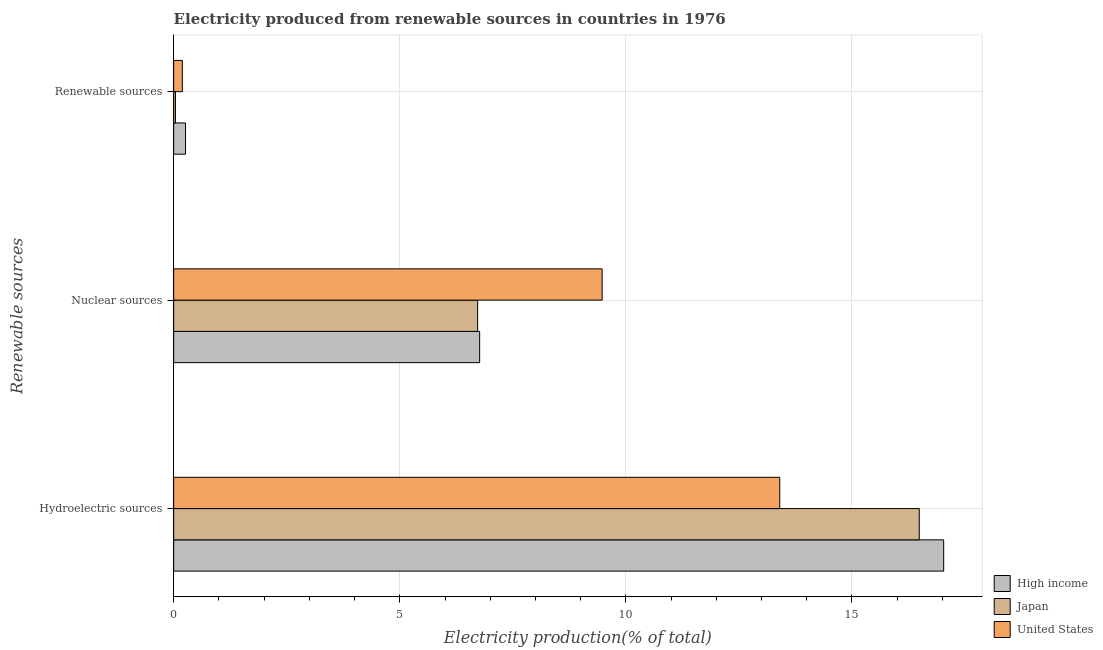Are the number of bars on each tick of the Y-axis equal?
Your answer should be compact. Yes. How many bars are there on the 2nd tick from the top?
Provide a succinct answer. 3. What is the label of the 2nd group of bars from the top?
Your answer should be compact. Nuclear sources. What is the percentage of electricity produced by nuclear sources in United States?
Provide a short and direct response. 9.47. Across all countries, what is the maximum percentage of electricity produced by nuclear sources?
Offer a terse response. 9.47. Across all countries, what is the minimum percentage of electricity produced by renewable sources?
Your answer should be very brief. 0.04. In which country was the percentage of electricity produced by renewable sources maximum?
Keep it short and to the point. High income. What is the total percentage of electricity produced by renewable sources in the graph?
Your response must be concise. 0.49. What is the difference between the percentage of electricity produced by renewable sources in Japan and that in High income?
Offer a very short reply. -0.22. What is the difference between the percentage of electricity produced by renewable sources in High income and the percentage of electricity produced by hydroelectric sources in United States?
Make the answer very short. -13.14. What is the average percentage of electricity produced by renewable sources per country?
Provide a succinct answer. 0.16. What is the difference between the percentage of electricity produced by nuclear sources and percentage of electricity produced by hydroelectric sources in High income?
Your response must be concise. -10.26. In how many countries, is the percentage of electricity produced by renewable sources greater than 8 %?
Your answer should be very brief. 0. What is the ratio of the percentage of electricity produced by hydroelectric sources in High income to that in Japan?
Offer a terse response. 1.03. What is the difference between the highest and the second highest percentage of electricity produced by renewable sources?
Provide a short and direct response. 0.07. What is the difference between the highest and the lowest percentage of electricity produced by hydroelectric sources?
Offer a very short reply. 3.63. Is the sum of the percentage of electricity produced by nuclear sources in United States and Japan greater than the maximum percentage of electricity produced by hydroelectric sources across all countries?
Provide a succinct answer. No. How many bars are there?
Give a very brief answer. 9. Are the values on the major ticks of X-axis written in scientific E-notation?
Offer a very short reply. No. How many legend labels are there?
Provide a short and direct response. 3. What is the title of the graph?
Provide a succinct answer. Electricity produced from renewable sources in countries in 1976. Does "Belize" appear as one of the legend labels in the graph?
Make the answer very short. No. What is the label or title of the Y-axis?
Ensure brevity in your answer.  Renewable sources. What is the Electricity production(% of total) of High income in Hydroelectric sources?
Provide a succinct answer. 17.03. What is the Electricity production(% of total) in Japan in Hydroelectric sources?
Offer a very short reply. 16.49. What is the Electricity production(% of total) of United States in Hydroelectric sources?
Your response must be concise. 13.4. What is the Electricity production(% of total) in High income in Nuclear sources?
Your answer should be compact. 6.77. What is the Electricity production(% of total) in Japan in Nuclear sources?
Your answer should be compact. 6.72. What is the Electricity production(% of total) of United States in Nuclear sources?
Keep it short and to the point. 9.47. What is the Electricity production(% of total) of High income in Renewable sources?
Keep it short and to the point. 0.26. What is the Electricity production(% of total) in Japan in Renewable sources?
Offer a very short reply. 0.04. What is the Electricity production(% of total) of United States in Renewable sources?
Make the answer very short. 0.19. Across all Renewable sources, what is the maximum Electricity production(% of total) in High income?
Your answer should be very brief. 17.03. Across all Renewable sources, what is the maximum Electricity production(% of total) of Japan?
Make the answer very short. 16.49. Across all Renewable sources, what is the maximum Electricity production(% of total) in United States?
Give a very brief answer. 13.4. Across all Renewable sources, what is the minimum Electricity production(% of total) in High income?
Your answer should be compact. 0.26. Across all Renewable sources, what is the minimum Electricity production(% of total) in Japan?
Offer a very short reply. 0.04. Across all Renewable sources, what is the minimum Electricity production(% of total) of United States?
Your answer should be very brief. 0.19. What is the total Electricity production(% of total) of High income in the graph?
Provide a succinct answer. 24.06. What is the total Electricity production(% of total) in Japan in the graph?
Ensure brevity in your answer.  23.25. What is the total Electricity production(% of total) of United States in the graph?
Your answer should be very brief. 23.07. What is the difference between the Electricity production(% of total) in High income in Hydroelectric sources and that in Nuclear sources?
Offer a terse response. 10.26. What is the difference between the Electricity production(% of total) in Japan in Hydroelectric sources and that in Nuclear sources?
Give a very brief answer. 9.77. What is the difference between the Electricity production(% of total) in United States in Hydroelectric sources and that in Nuclear sources?
Offer a terse response. 3.93. What is the difference between the Electricity production(% of total) of High income in Hydroelectric sources and that in Renewable sources?
Keep it short and to the point. 16.77. What is the difference between the Electricity production(% of total) of Japan in Hydroelectric sources and that in Renewable sources?
Provide a short and direct response. 16.45. What is the difference between the Electricity production(% of total) in United States in Hydroelectric sources and that in Renewable sources?
Provide a succinct answer. 13.21. What is the difference between the Electricity production(% of total) in High income in Nuclear sources and that in Renewable sources?
Offer a very short reply. 6.5. What is the difference between the Electricity production(% of total) in Japan in Nuclear sources and that in Renewable sources?
Offer a terse response. 6.68. What is the difference between the Electricity production(% of total) of United States in Nuclear sources and that in Renewable sources?
Offer a very short reply. 9.28. What is the difference between the Electricity production(% of total) in High income in Hydroelectric sources and the Electricity production(% of total) in Japan in Nuclear sources?
Your response must be concise. 10.31. What is the difference between the Electricity production(% of total) of High income in Hydroelectric sources and the Electricity production(% of total) of United States in Nuclear sources?
Make the answer very short. 7.55. What is the difference between the Electricity production(% of total) in Japan in Hydroelectric sources and the Electricity production(% of total) in United States in Nuclear sources?
Make the answer very short. 7.01. What is the difference between the Electricity production(% of total) in High income in Hydroelectric sources and the Electricity production(% of total) in Japan in Renewable sources?
Your response must be concise. 16.99. What is the difference between the Electricity production(% of total) in High income in Hydroelectric sources and the Electricity production(% of total) in United States in Renewable sources?
Your answer should be compact. 16.84. What is the difference between the Electricity production(% of total) in Japan in Hydroelectric sources and the Electricity production(% of total) in United States in Renewable sources?
Keep it short and to the point. 16.3. What is the difference between the Electricity production(% of total) of High income in Nuclear sources and the Electricity production(% of total) of Japan in Renewable sources?
Your answer should be very brief. 6.73. What is the difference between the Electricity production(% of total) in High income in Nuclear sources and the Electricity production(% of total) in United States in Renewable sources?
Offer a very short reply. 6.57. What is the difference between the Electricity production(% of total) of Japan in Nuclear sources and the Electricity production(% of total) of United States in Renewable sources?
Offer a very short reply. 6.53. What is the average Electricity production(% of total) in High income per Renewable sources?
Make the answer very short. 8.02. What is the average Electricity production(% of total) in Japan per Renewable sources?
Your response must be concise. 7.75. What is the average Electricity production(% of total) of United States per Renewable sources?
Offer a very short reply. 7.69. What is the difference between the Electricity production(% of total) of High income and Electricity production(% of total) of Japan in Hydroelectric sources?
Provide a succinct answer. 0.54. What is the difference between the Electricity production(% of total) of High income and Electricity production(% of total) of United States in Hydroelectric sources?
Provide a short and direct response. 3.63. What is the difference between the Electricity production(% of total) in Japan and Electricity production(% of total) in United States in Hydroelectric sources?
Your response must be concise. 3.08. What is the difference between the Electricity production(% of total) in High income and Electricity production(% of total) in Japan in Nuclear sources?
Your response must be concise. 0.04. What is the difference between the Electricity production(% of total) in High income and Electricity production(% of total) in United States in Nuclear sources?
Offer a terse response. -2.71. What is the difference between the Electricity production(% of total) in Japan and Electricity production(% of total) in United States in Nuclear sources?
Offer a terse response. -2.75. What is the difference between the Electricity production(% of total) of High income and Electricity production(% of total) of Japan in Renewable sources?
Provide a succinct answer. 0.22. What is the difference between the Electricity production(% of total) in High income and Electricity production(% of total) in United States in Renewable sources?
Provide a succinct answer. 0.07. What is the difference between the Electricity production(% of total) of Japan and Electricity production(% of total) of United States in Renewable sources?
Your answer should be very brief. -0.15. What is the ratio of the Electricity production(% of total) of High income in Hydroelectric sources to that in Nuclear sources?
Ensure brevity in your answer.  2.52. What is the ratio of the Electricity production(% of total) in Japan in Hydroelectric sources to that in Nuclear sources?
Your response must be concise. 2.45. What is the ratio of the Electricity production(% of total) in United States in Hydroelectric sources to that in Nuclear sources?
Offer a very short reply. 1.41. What is the ratio of the Electricity production(% of total) in High income in Hydroelectric sources to that in Renewable sources?
Your answer should be very brief. 64.9. What is the ratio of the Electricity production(% of total) of Japan in Hydroelectric sources to that in Renewable sources?
Give a very brief answer. 417.95. What is the ratio of the Electricity production(% of total) of United States in Hydroelectric sources to that in Renewable sources?
Provide a short and direct response. 69.94. What is the ratio of the Electricity production(% of total) of High income in Nuclear sources to that in Renewable sources?
Your response must be concise. 25.79. What is the ratio of the Electricity production(% of total) of Japan in Nuclear sources to that in Renewable sources?
Keep it short and to the point. 170.4. What is the ratio of the Electricity production(% of total) in United States in Nuclear sources to that in Renewable sources?
Ensure brevity in your answer.  49.44. What is the difference between the highest and the second highest Electricity production(% of total) of High income?
Offer a terse response. 10.26. What is the difference between the highest and the second highest Electricity production(% of total) in Japan?
Provide a succinct answer. 9.77. What is the difference between the highest and the second highest Electricity production(% of total) in United States?
Provide a short and direct response. 3.93. What is the difference between the highest and the lowest Electricity production(% of total) of High income?
Provide a short and direct response. 16.77. What is the difference between the highest and the lowest Electricity production(% of total) of Japan?
Your response must be concise. 16.45. What is the difference between the highest and the lowest Electricity production(% of total) in United States?
Provide a succinct answer. 13.21. 